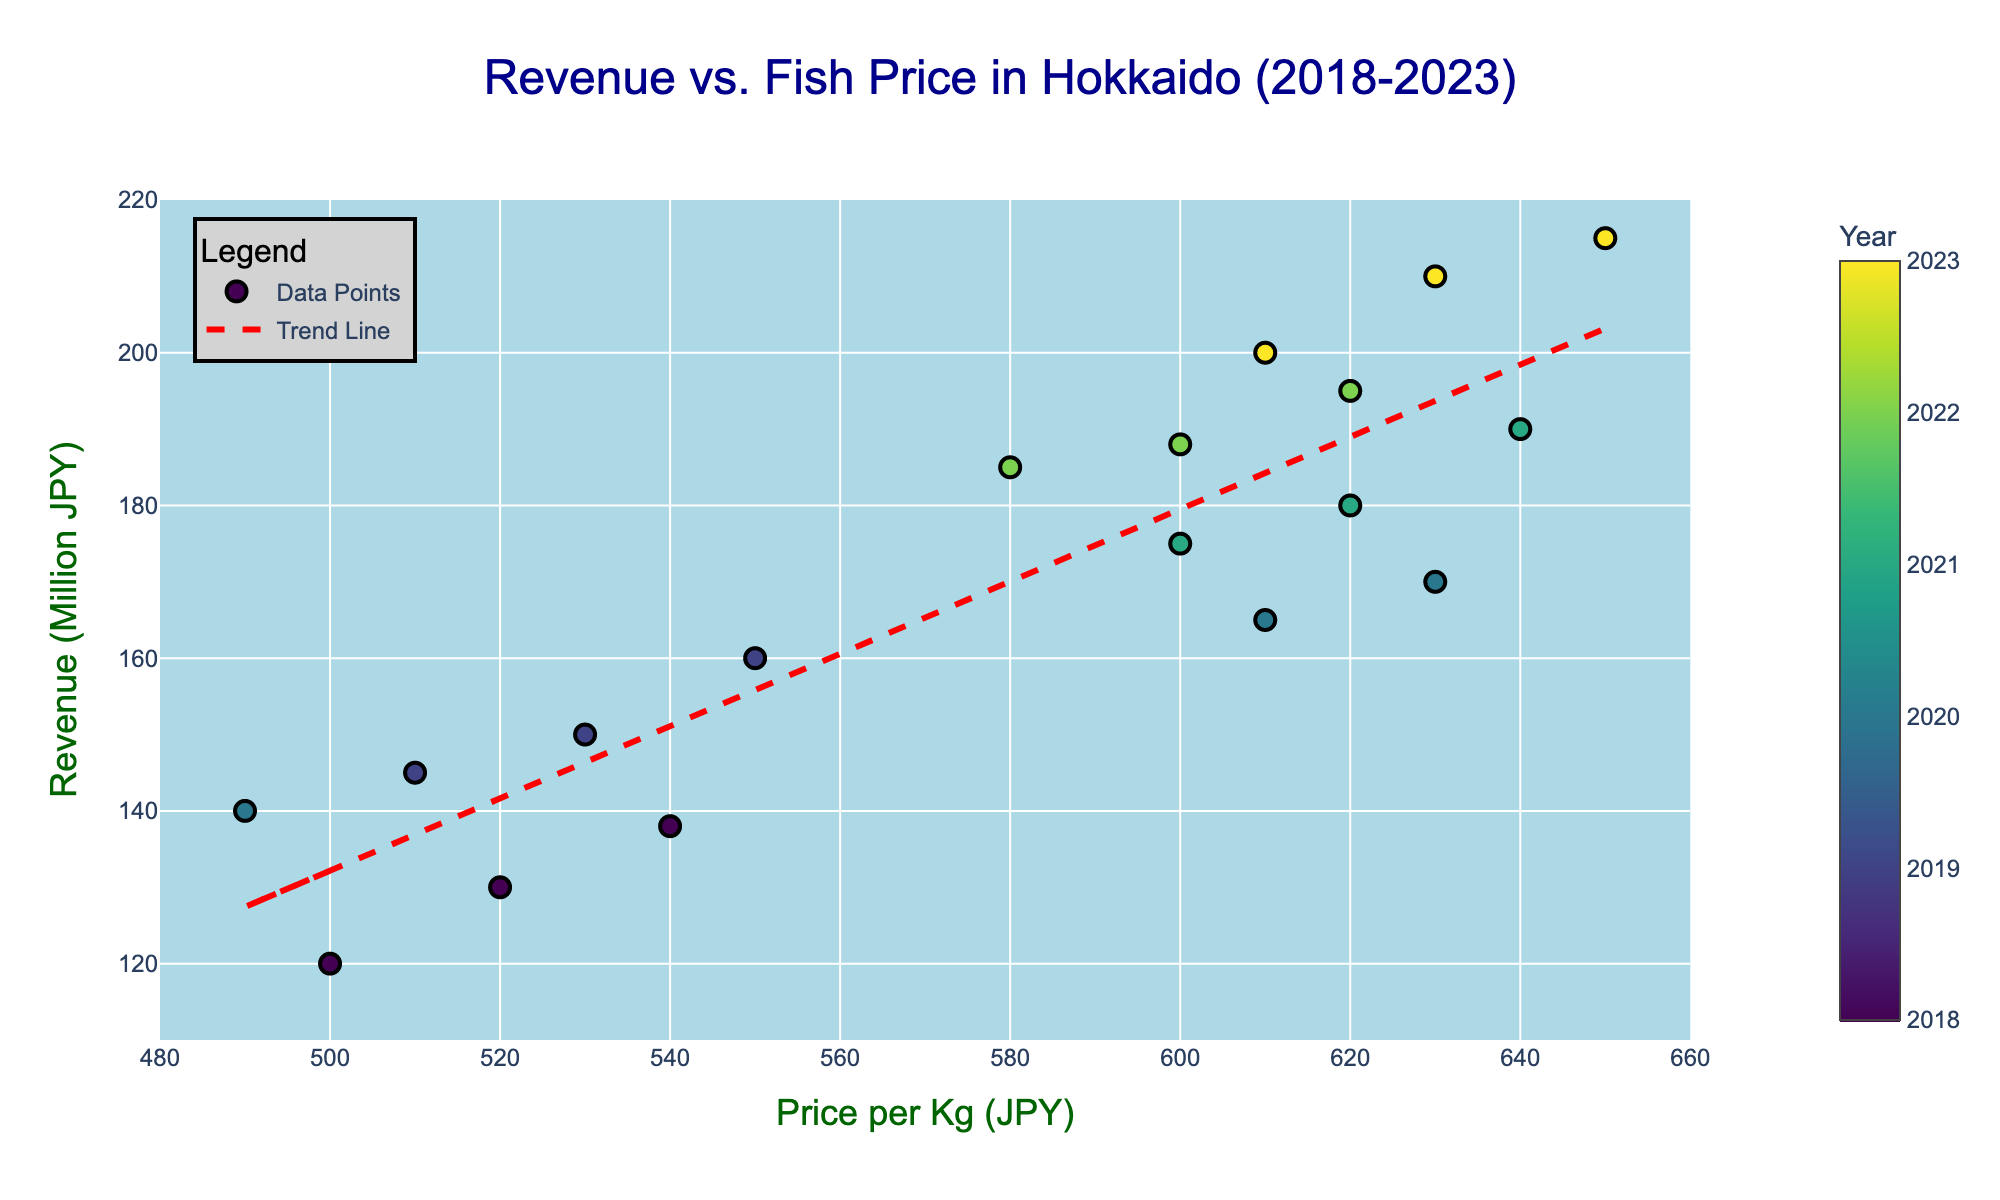What is the title of the figure? The title of the figure is displayed at the top center of the plot. It states "Revenue vs. Fish Price in Hokkaido (2018-2023)."
Answer: Revenue vs. Fish Price in Hokkaido (2018-2023) How many data points are there in the plot? Each marker represents a data point and by counting the distinct markers, we see there are 18 data points.
Answer: 18 What is the color and purpose of the line indicating the trend? The line is red and dashed, signifying the trend line representing the linear relationship between fish price per kilogram and revenue.
Answer: Red and dashed What is the range of the x-axis for Price per Kg? The x-axis for Price per Kg ranges from 480 to 660, as shown by the axis labels.
Answer: 480 to 660 How has the revenue changed as the Price per Kg increased from 500 JPY to 650 JPY? By examining the scatter plot and trend line, it can be observed that the revenue has generally increased as the price per Kg increased from 500 JPY to 650 JPY, with the trend line indicating this positive correlation.
Answer: Increased Which year had the most revenue even at a lower Price per Kg than in 2023? Referring to the color scale and corresponding years, 2021 has a point around Price per Kg = 600 JPY with revenue around 180 Million JPY, which is higher compared to lower prices in 2023.
Answer: 2021 What is the approximate slope of the trend line? The slope of the trend line can be approximated by taking two points on the line and finding the change in y divided by the change in x. From the trend line, picking (500, 120) and (650, 210) gives a slope of (210 - 120)/(650 - 500), resulting in approximately 0.6.
Answer: 0.6 Which year appears to have the highest concentration of data points? By observing the colors represented by the color scale, 2023 shows a tight cluster of data points, indicating it has the highest concentration.
Answer: 2023 Does the plot indicate a stronger or weaker correlation between fish price and revenue in recent years (2021-2023) compared to earlier years? In recent years (2021-2023), the plot shows a tighter clustering and higher revenue at higher prices, which suggests a stronger correlation as compared to the more spread out points of earlier years (2018-2020).
Answer: Stronger 